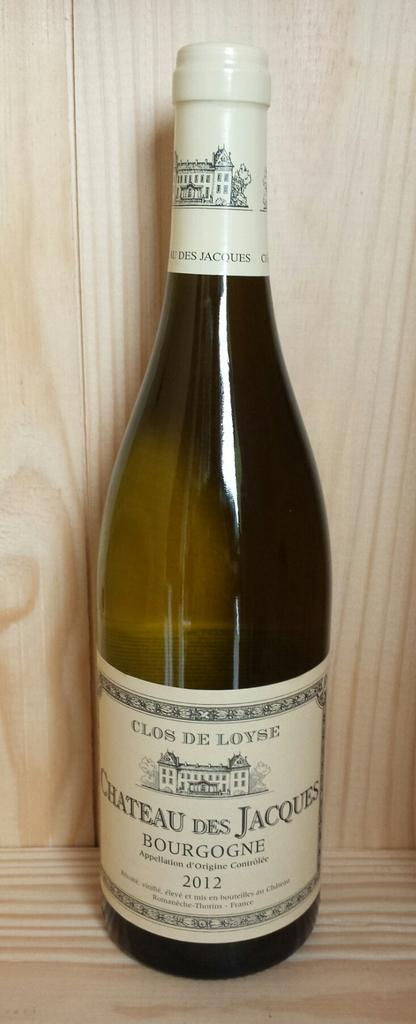<image>
Render a clear and concise summary of the photo. A bottle of Clos de Loyse was made in 2012. 